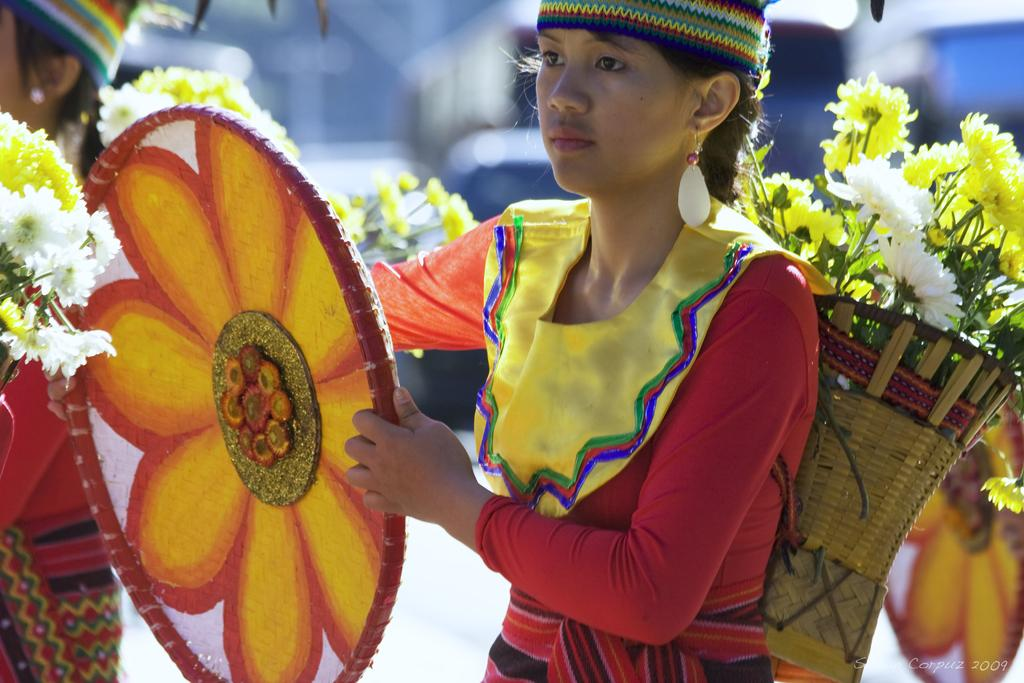How many people are in the image? There are two persons in the image. What are the persons doing in the image? The persons are walking. What are they carrying while walking? They are carrying flowers in a basket. Can you describe the object held by one of the ladies? One of the ladies is holding an object in her hand. What type of spy equipment can be seen in the image? There is no spy equipment present in the image. How many feet are visible in the image? The number of feet visible in the image cannot be determined from the provided facts. 